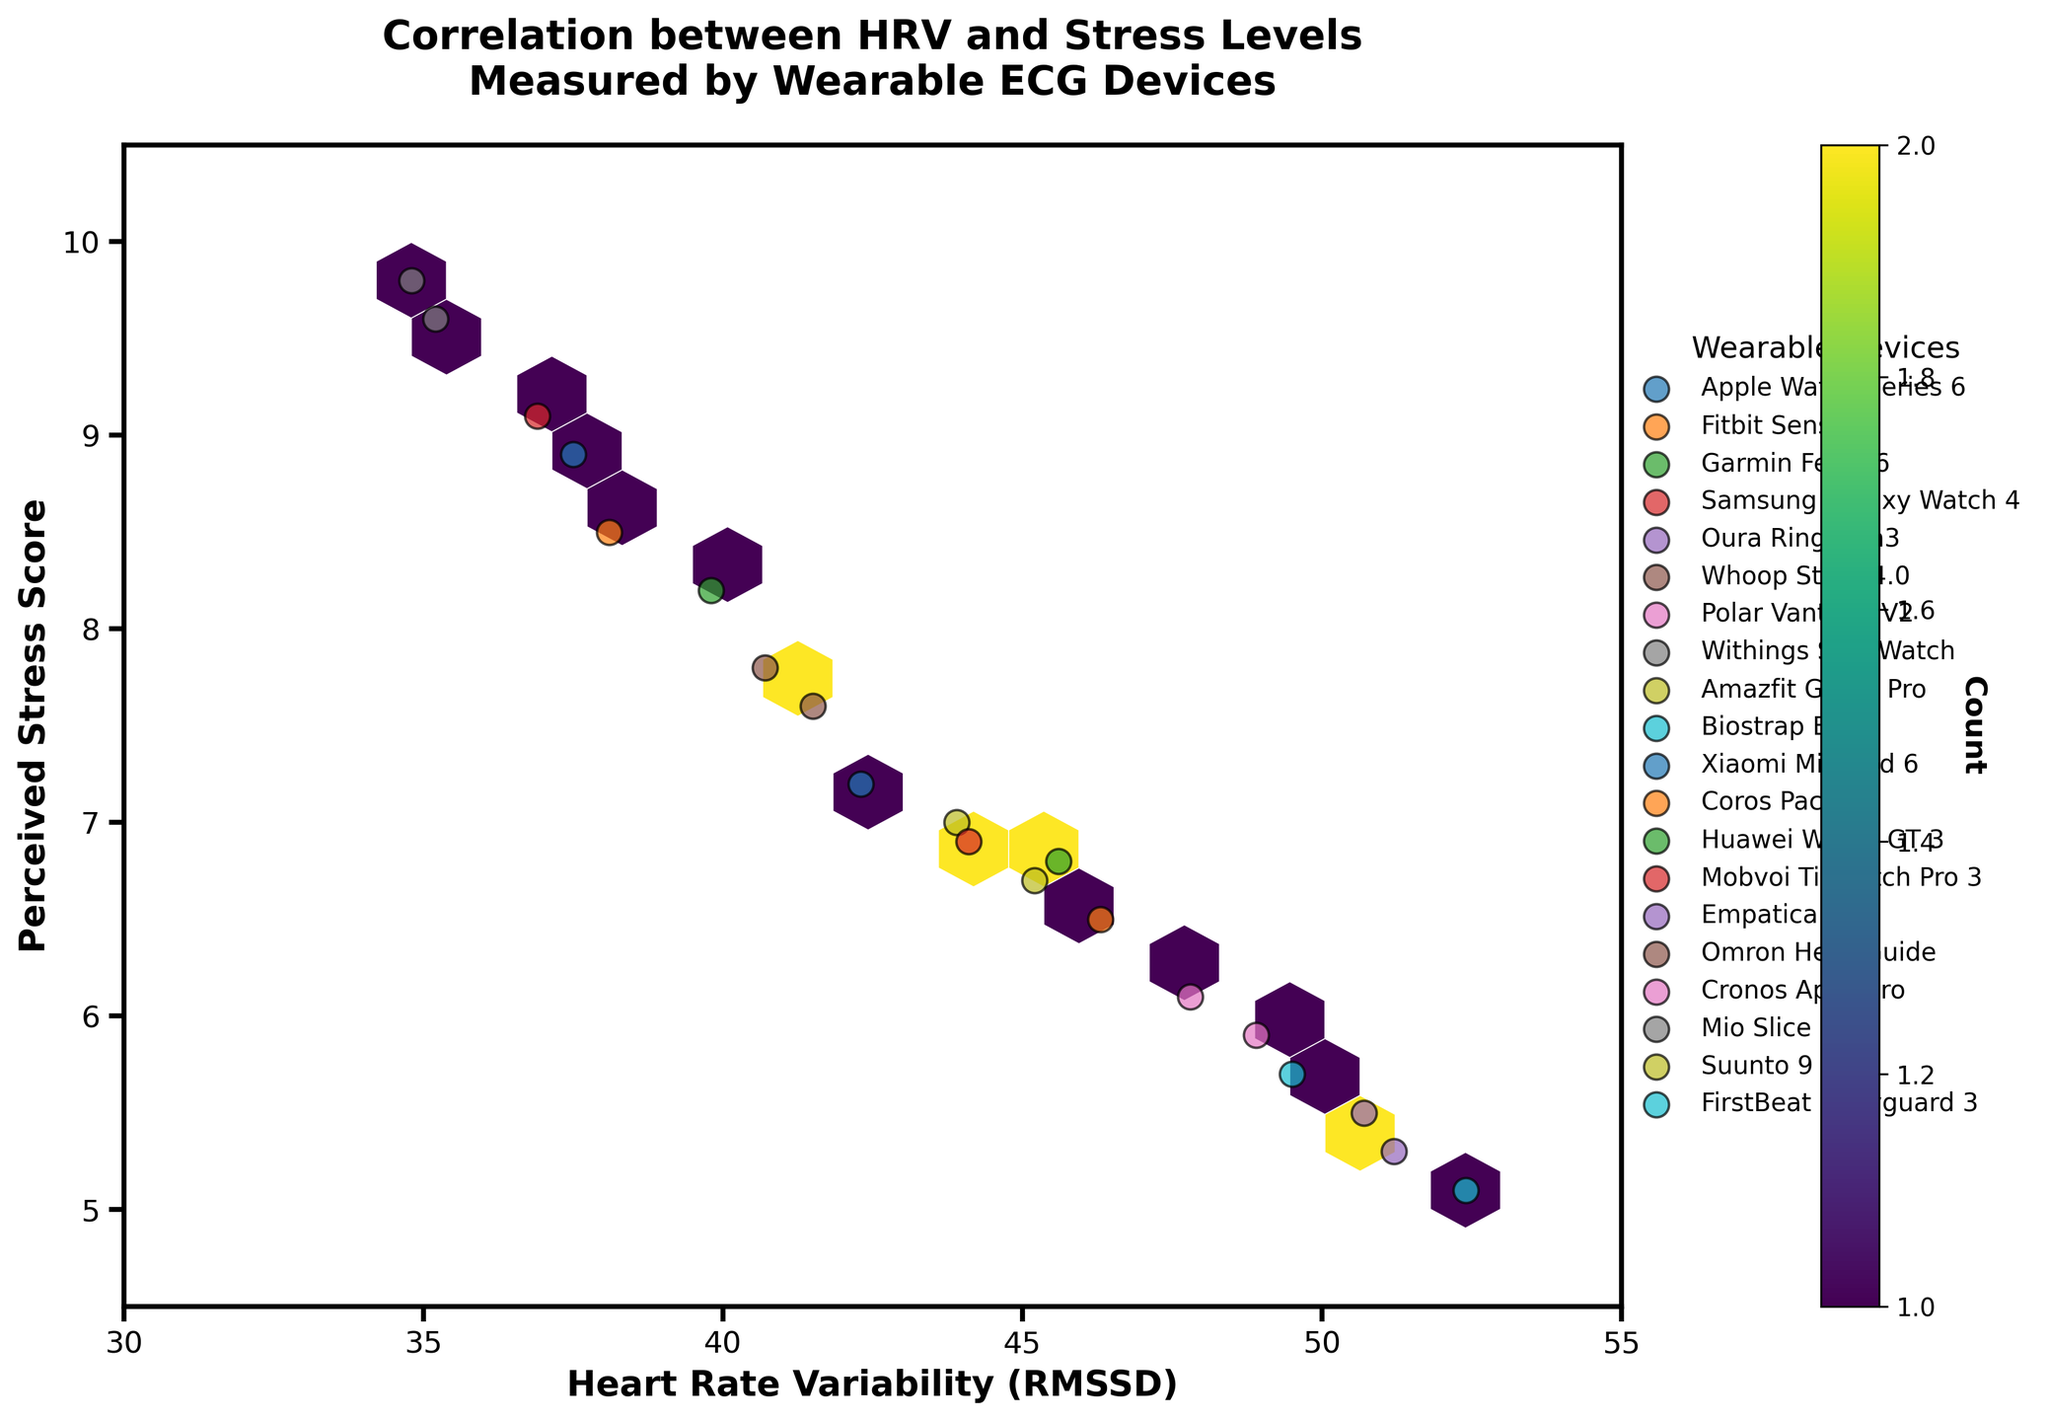What's the title of the plot? The title of the plot is displayed at the top of the figure. It reads "Correlation between HRV and Stress Levels Measured by Wearable ECG Devices."
Answer: Correlation between HRV and Stress Levels Measured by Wearable ECG Devices What is represented on the x-axis? The x-axis label is visible below the plot. It denotes "Heart Rate Variability (RMSSD)."
Answer: Heart Rate Variability (RMSSD) What is represented on the y-axis? The y-axis label is visible to the left of the plot. It denotes "Perceived Stress Score."
Answer: Perceived Stress Score Which color map is used in the hexbin plot? The hexbin plot uses a color gradient ranging from green to yellowish-green to represent different densities. The colormap used is 'viridis.'
Answer: viridis What does the color intensity represent in the plot? The color intensity in the hexbin plot indicates the count of data points within each hexagonal bin. More intense colors represent higher counts.
Answer: Count of data points Which device is associated with the lowest perceived stress score? By looking at the scatter points and their associated labels, "FirstBeat Bodyguard 3" shows the lowest perceived stress score of 5.1.
Answer: FirstBeat Bodyguard 3 Which device shows the highest HRV RMSSD value? The scatter points and their labels indicate the "FirstBeat Bodyguard 3" also shows the highest HRV RMSSD value of 52.4.
Answer: FirstBeat Bodyguard 3 What is the range of the x-axis? The x-axis range is presented by the axis limits shown at the bottom of the plot, ranging from 30 to 55.
Answer: 30 to 55 What is the range of the y-axis? The y-axis range is presented by the axis limits shown to the left of the plot, ranging from 4.5 to 10.5.
Answer: 4.5 to 10.5 Which wearable device has an HRV RMSSD value closest to 40 and a perceived stress score closer to 8? Scanning the scatter points with labels reveals that the "Huawei Watch GT 3" has an HRV RMSSD value of 39.8 and a perceived stress score of 8.2.
Answer: Huawei Watch GT 3 